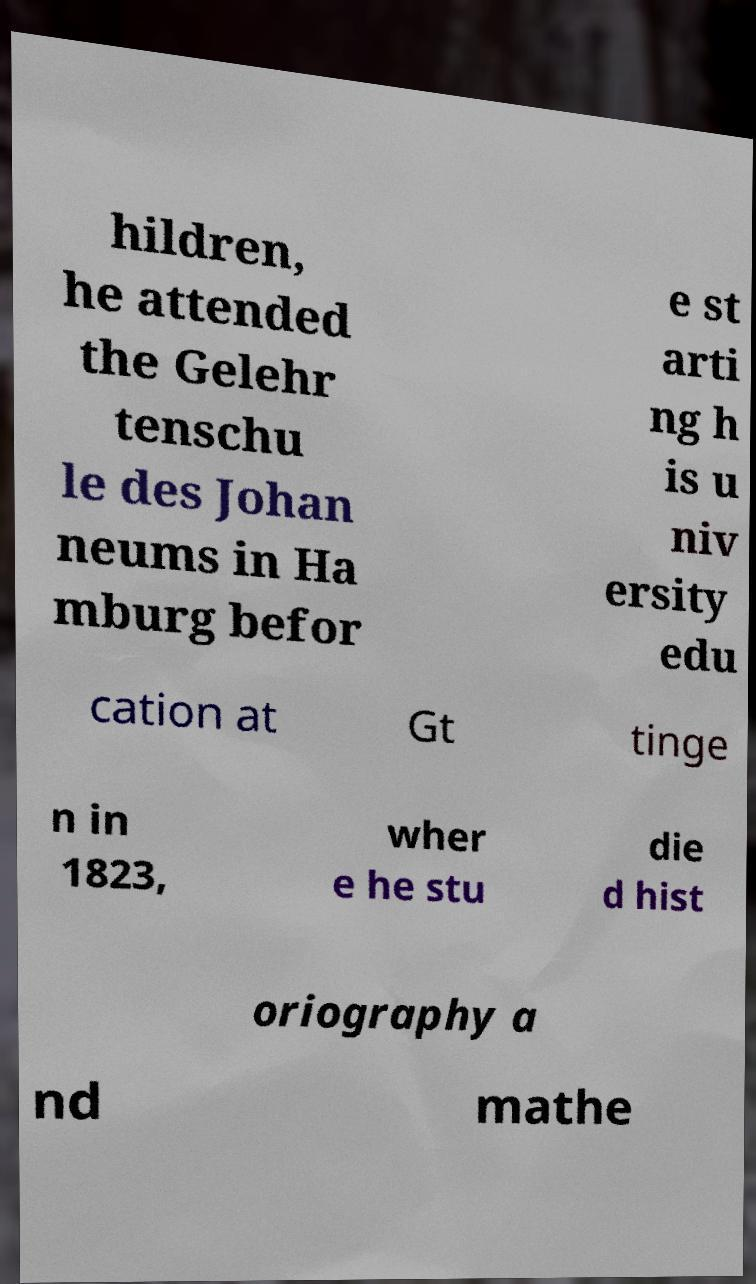There's text embedded in this image that I need extracted. Can you transcribe it verbatim? hildren, he attended the Gelehr tenschu le des Johan neums in Ha mburg befor e st arti ng h is u niv ersity edu cation at Gt tinge n in 1823, wher e he stu die d hist oriography a nd mathe 